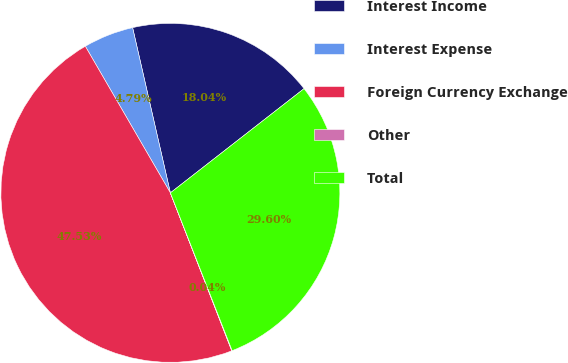<chart> <loc_0><loc_0><loc_500><loc_500><pie_chart><fcel>Interest Income<fcel>Interest Expense<fcel>Foreign Currency Exchange<fcel>Other<fcel>Total<nl><fcel>18.04%<fcel>4.79%<fcel>47.53%<fcel>0.04%<fcel>29.6%<nl></chart> 